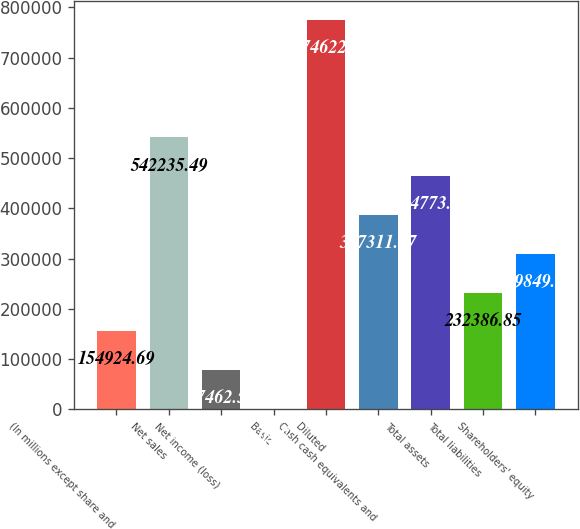<chart> <loc_0><loc_0><loc_500><loc_500><bar_chart><fcel>(In millions except share and<fcel>Net sales<fcel>Net income (loss)<fcel>Basic<fcel>Diluted<fcel>Cash cash equivalents and<fcel>Total assets<fcel>Total liabilities<fcel>Shareholders' equity<nl><fcel>154925<fcel>542235<fcel>77462.5<fcel>0.37<fcel>774622<fcel>387311<fcel>464773<fcel>232387<fcel>309849<nl></chart> 